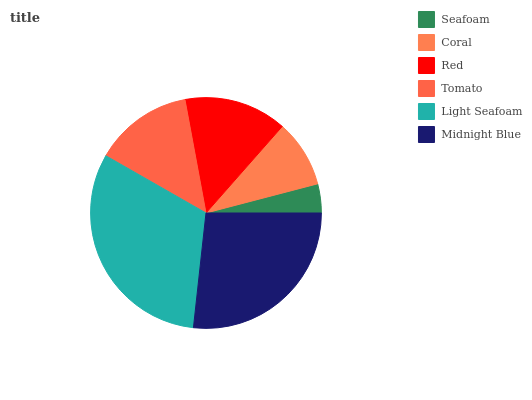Is Seafoam the minimum?
Answer yes or no. Yes. Is Light Seafoam the maximum?
Answer yes or no. Yes. Is Coral the minimum?
Answer yes or no. No. Is Coral the maximum?
Answer yes or no. No. Is Coral greater than Seafoam?
Answer yes or no. Yes. Is Seafoam less than Coral?
Answer yes or no. Yes. Is Seafoam greater than Coral?
Answer yes or no. No. Is Coral less than Seafoam?
Answer yes or no. No. Is Red the high median?
Answer yes or no. Yes. Is Tomato the low median?
Answer yes or no. Yes. Is Midnight Blue the high median?
Answer yes or no. No. Is Midnight Blue the low median?
Answer yes or no. No. 